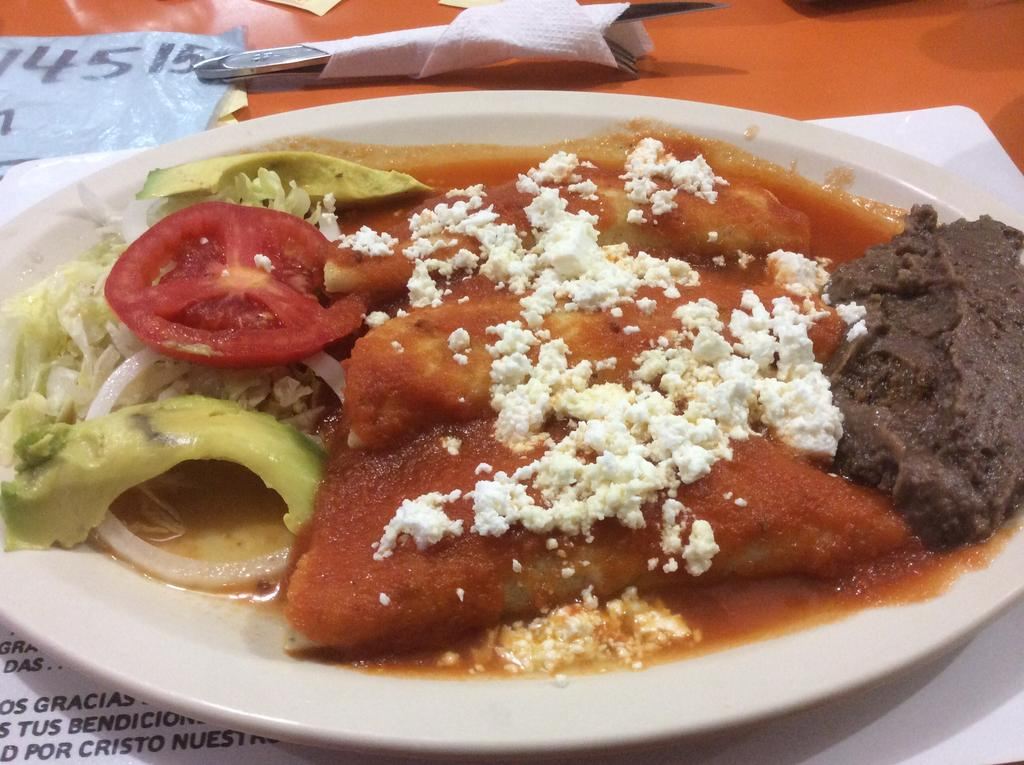What is on the plate in the image? There is food on a plate in the image. What can be seen in the background of the image? There are papers with text in the background of the image. What object is visible that might hold something? There is a holder visible in the image. What item is placed on the table in the image? A tissue is placed on the table in the image. What type of crown is the toad wearing in the image? There is no toad or crown present in the image. 